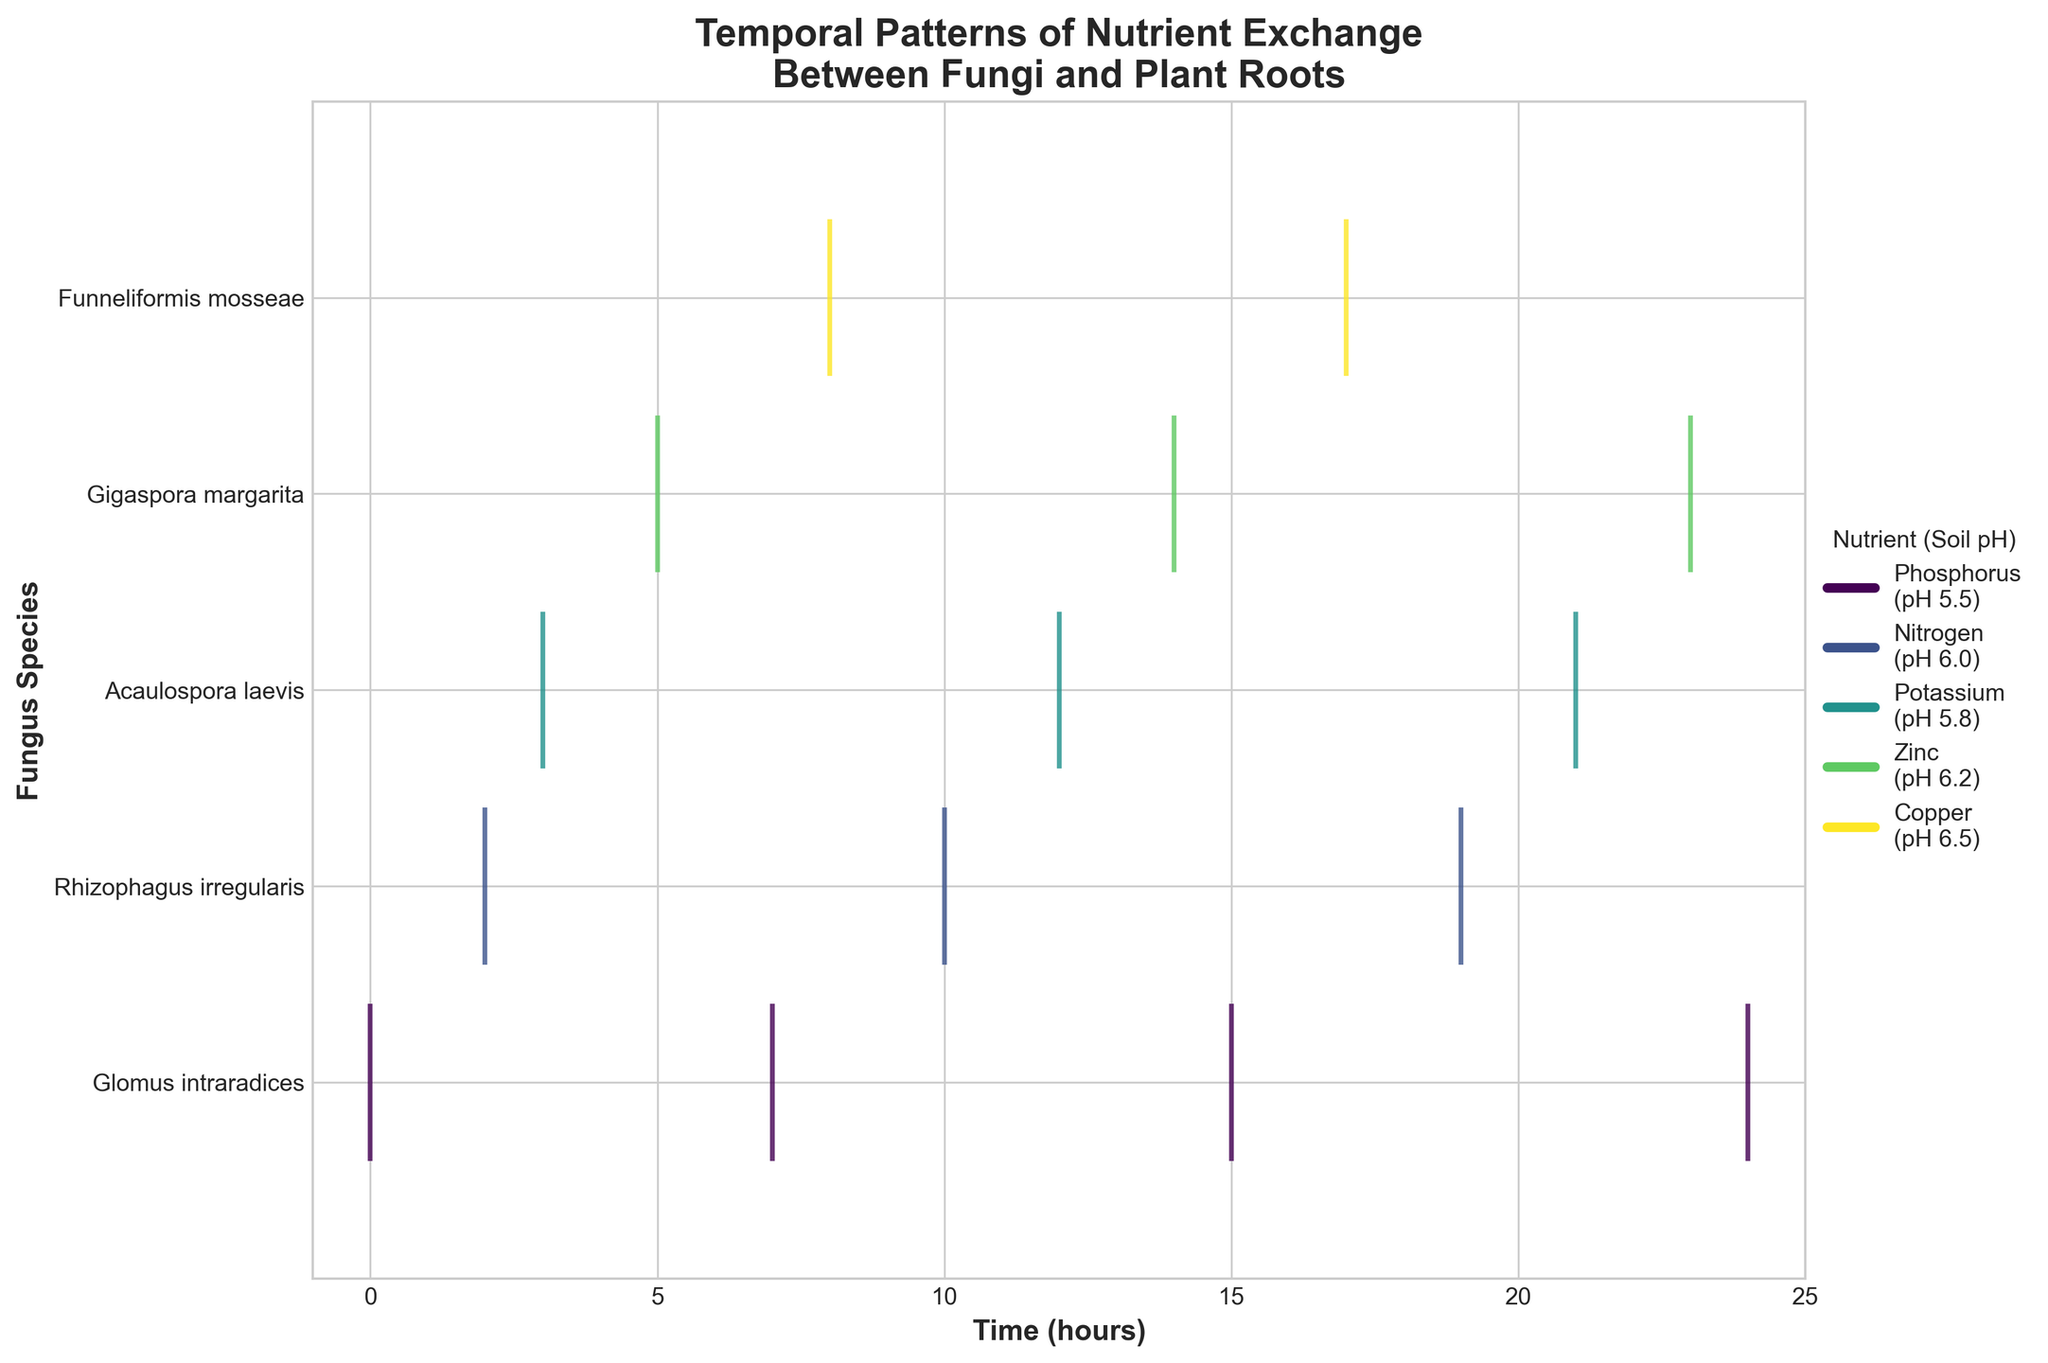1. What is the title of the graph? The title is located at the top of the graph. It is labeled "Temporal Patterns of Nutrient Exchange Between Fungi and Plant Roots."
Answer: Temporal Patterns of Nutrient Exchange Between Fungi and Plant Roots 2. How many fungus species are displayed on the y-axis? The y-axis lists the fungus species. There are five labels indicating five fungus species.
Answer: Five 3. What is the time range depicted on the x-axis? The x-axis labels the time in hours. It starts from hour 0 and ends at hour 24.
Answer: 0 to 24 hours 4. How often do exchange events involving Glomus intraradices occur? The exchange events for Glomus intraradices appear at regular intervals. By inspecting the even spacing and counting the events, we see they occur every 7-9 hours, roughly every 8 hours.
Answer: 8 hours 5. Which nutrient was exchanged the most frequently and how many times did it occur? By examining the legend and the colored lines, notice the nutrient - phosphorus, associated with Glomus intraradices, appears most frequently. Count the total events for phosphorus to find it occurs 5 times.
Answer: Phosphorus, 5 times 6. Between Rhizophagus irregularis and Acaulospora laevis, which had more exchange events? Count the number of events (colored lines) for Rhizophagus irregularis and Acaulospora laevis, and compare the totals. Rhizophagus irregularis had 3 events, while Acaulospora laevis had 3 events.
Answer: Both have the same 7. Do any fungus species show exchange events consistently at the same pH levels? Look at the legend and the colors used for different pH values corresponding to each species. Notice Glomus intraradices consistently shows all its exchange events at pH 5.5.
Answer: Yes, Glomus intraradices 8. How are the different fungus species differentiated in the event plot? The different fungus species are differentiated by their positions on the y-axis, and each species is represented by a distinct line of events at various time points.
Answer: Positions on y-axis and distinct line of events 9. Which fungus species has the first exchange event, and at what time? The first exchange event is the leftmost event at time 0. It corresponds to Glomus intraradices.
Answer: Glomus intraradices at time 0 10. Can you identify a pattern in the exchange events of Gigaspora margarita? Observing the events for Gigaspora margarita (fourth on y-axis), there is a consistent time interval of 9 hours between each of its events.
Answer: Consistent 9-hour intervals 